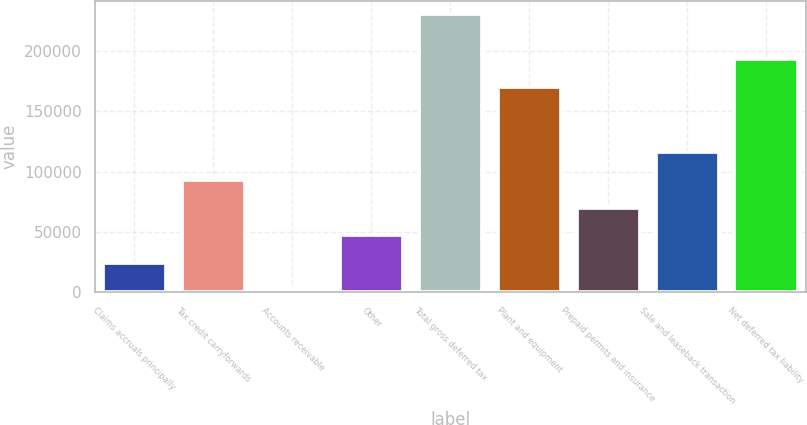<chart> <loc_0><loc_0><loc_500><loc_500><bar_chart><fcel>Claims accruals principally<fcel>Tax credit carryforwards<fcel>Accounts receivable<fcel>Other<fcel>Total gross deferred tax<fcel>Plant and equipment<fcel>Prepaid permits and insurance<fcel>Sale and leaseback transaction<fcel>Net deferred tax liability<nl><fcel>24615.1<fcel>93024.4<fcel>1812<fcel>47418.2<fcel>229843<fcel>169515<fcel>70221.3<fcel>115828<fcel>192690<nl></chart> 